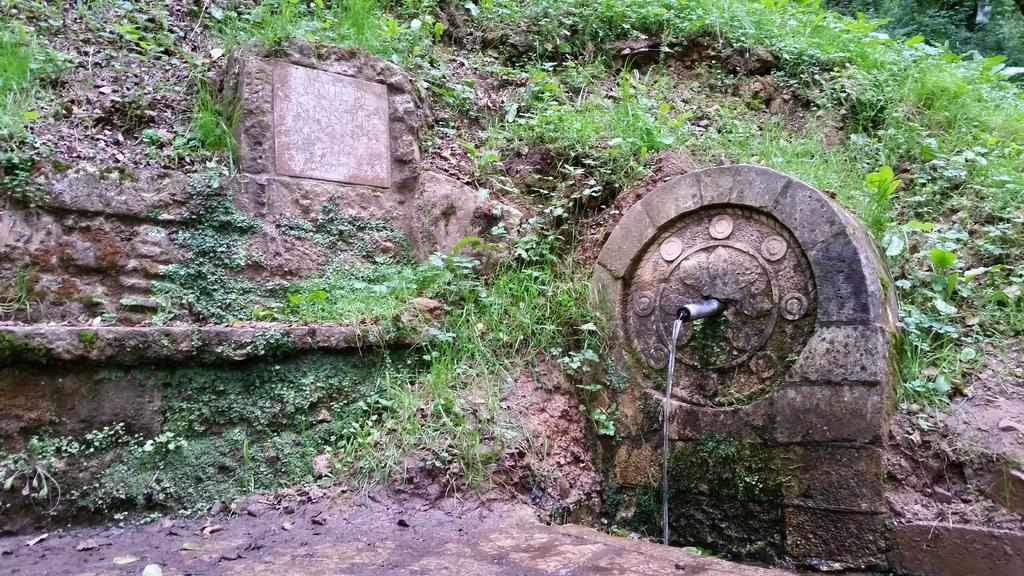What is the source of the water in the image? There is an object in the image from which water is coming. What type of natural environment can be seen in the background of the image? There is grass and plants visible in the background of the image. How many eggs are present in the image? There are no eggs visible in the image. What type of ground is shown in the image? The ground is not visible in the image, as the focus is on the water and the background environment. 